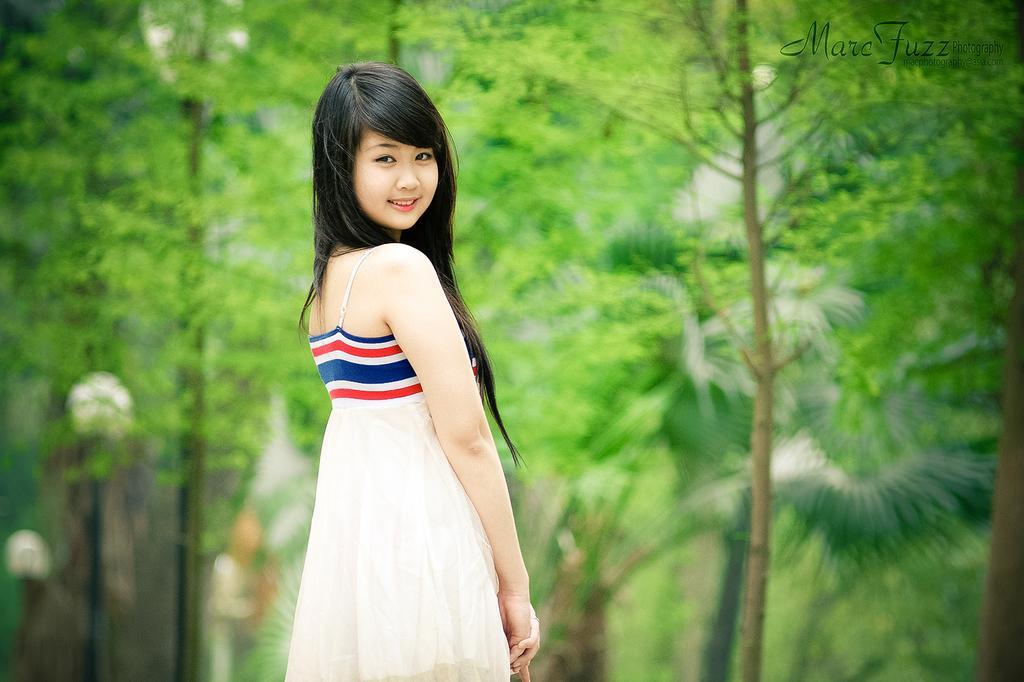Please provide a concise description of this image. In the picture I can see a woman is standing and smiling. In the background I can see trees. On the top right corner of the image I can see a watermark. The background of the image is blurred. 